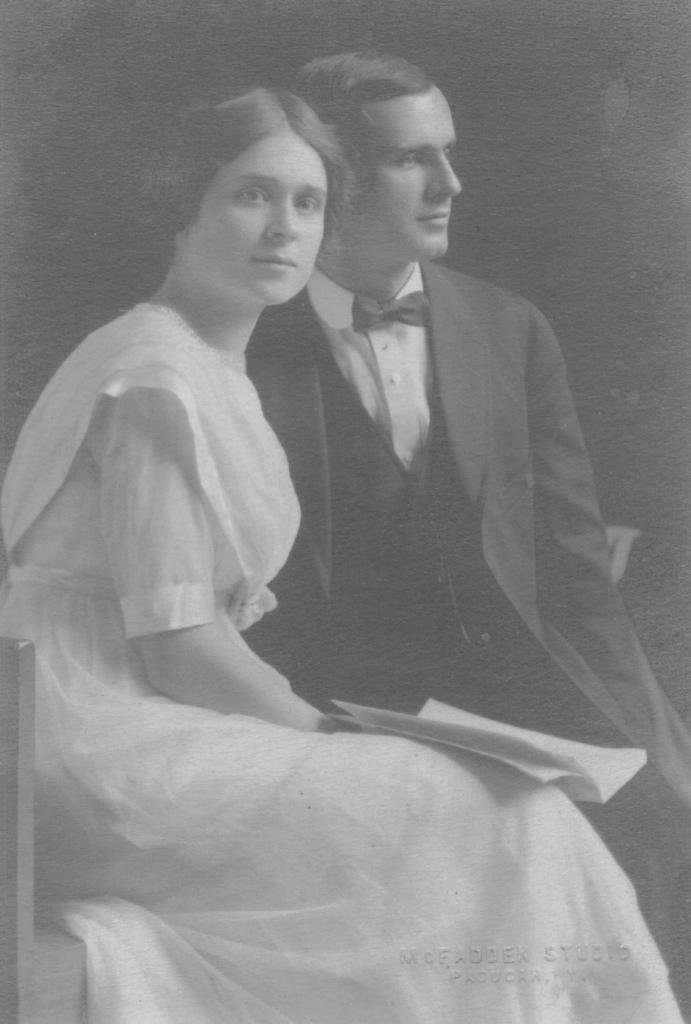Describe this image in one or two sentences. In this picture I can see there is a woman sitting and she is wearing a white dress and holding a book and the man is wearing black blazer and he is looking at right and the backdrop is dark. 